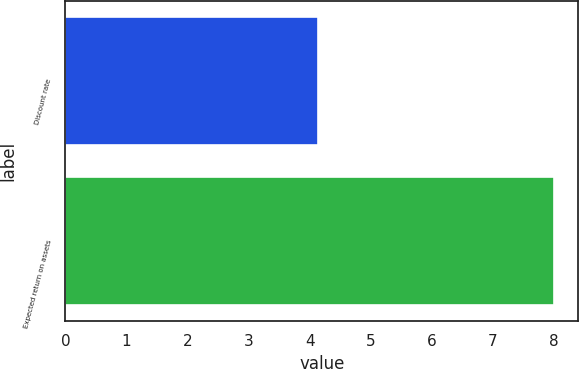Convert chart to OTSL. <chart><loc_0><loc_0><loc_500><loc_500><bar_chart><fcel>Discount rate<fcel>Expected return on assets<nl><fcel>4.14<fcel>8<nl></chart> 